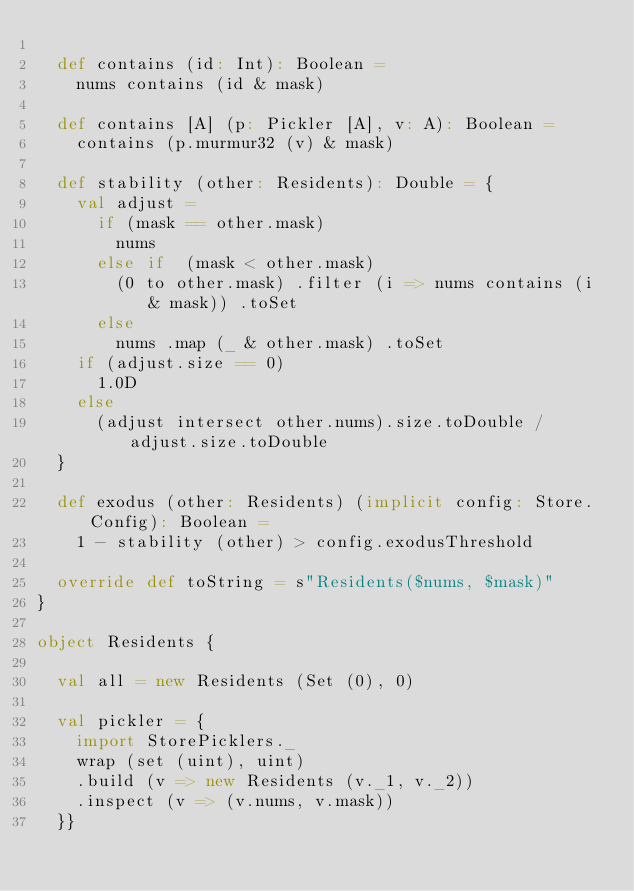<code> <loc_0><loc_0><loc_500><loc_500><_Scala_>
  def contains (id: Int): Boolean =
    nums contains (id & mask)

  def contains [A] (p: Pickler [A], v: A): Boolean =
    contains (p.murmur32 (v) & mask)

  def stability (other: Residents): Double = {
    val adjust =
      if (mask == other.mask)
        nums
      else if  (mask < other.mask)
        (0 to other.mask) .filter (i => nums contains (i & mask)) .toSet
      else
        nums .map (_ & other.mask) .toSet
    if (adjust.size == 0)
      1.0D
    else
      (adjust intersect other.nums).size.toDouble / adjust.size.toDouble
  }

  def exodus (other: Residents) (implicit config: Store.Config): Boolean =
    1 - stability (other) > config.exodusThreshold

  override def toString = s"Residents($nums, $mask)"
}

object Residents {

  val all = new Residents (Set (0), 0)

  val pickler = {
    import StorePicklers._
    wrap (set (uint), uint)
    .build (v => new Residents (v._1, v._2))
    .inspect (v => (v.nums, v.mask))
  }}
</code> 